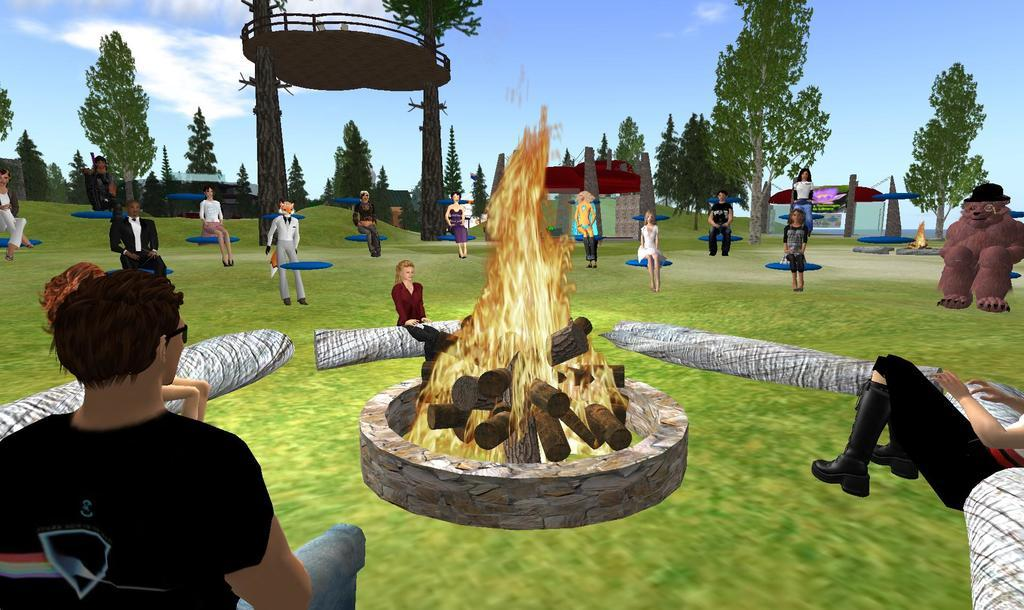What are the people in the image doing? Some people are standing, and some are sitting in the image. What can be seen in the image besides the people? There is a bonfire in the image. What type of natural environment is visible in the image? There are trees in the image, indicating a forest or wooded area. What is visible in the sky in the image? The sky is visible in the image, but no specific details about the sky are mentioned in the facts. What type of oatmeal is being served at the bonfire in the image? There is no mention of oatmeal in the image or the provided facts, so it cannot be determined if oatmeal is present or being served. 